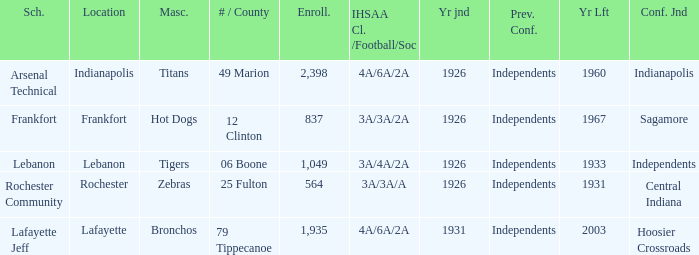What is the average enrollment that has hot dogs as the mascot, with a year joined later than 1926? None. 